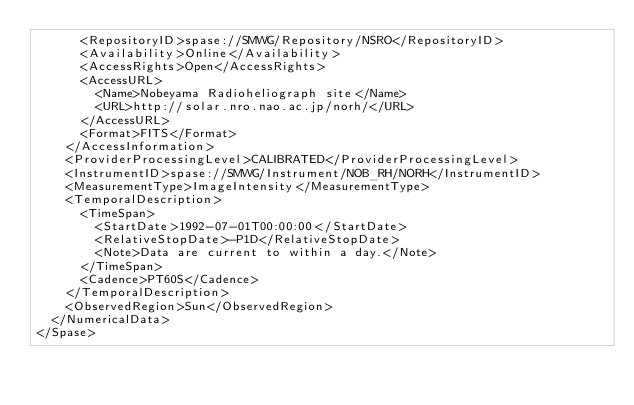<code> <loc_0><loc_0><loc_500><loc_500><_XML_>      <RepositoryID>spase://SMWG/Repository/NSRO</RepositoryID>
      <Availability>Online</Availability>
      <AccessRights>Open</AccessRights>
      <AccessURL>
        <Name>Nobeyama Radioheliograph site</Name>
        <URL>http://solar.nro.nao.ac.jp/norh/</URL>
      </AccessURL>
      <Format>FITS</Format>
    </AccessInformation>
    <ProviderProcessingLevel>CALIBRATED</ProviderProcessingLevel>
    <InstrumentID>spase://SMWG/Instrument/NOB_RH/NORH</InstrumentID>
    <MeasurementType>ImageIntensity</MeasurementType>
    <TemporalDescription>
      <TimeSpan>
        <StartDate>1992-07-01T00:00:00</StartDate>
        <RelativeStopDate>-P1D</RelativeStopDate>
        <Note>Data are current to within a day.</Note>
      </TimeSpan>
      <Cadence>PT60S</Cadence>
    </TemporalDescription>
    <ObservedRegion>Sun</ObservedRegion>
  </NumericalData>
</Spase>
</code> 